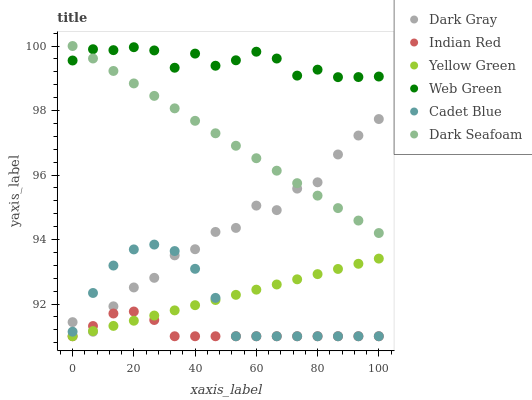Does Indian Red have the minimum area under the curve?
Answer yes or no. Yes. Does Web Green have the maximum area under the curve?
Answer yes or no. Yes. Does Yellow Green have the minimum area under the curve?
Answer yes or no. No. Does Yellow Green have the maximum area under the curve?
Answer yes or no. No. Is Yellow Green the smoothest?
Answer yes or no. Yes. Is Dark Gray the roughest?
Answer yes or no. Yes. Is Web Green the smoothest?
Answer yes or no. No. Is Web Green the roughest?
Answer yes or no. No. Does Cadet Blue have the lowest value?
Answer yes or no. Yes. Does Web Green have the lowest value?
Answer yes or no. No. Does Dark Seafoam have the highest value?
Answer yes or no. Yes. Does Yellow Green have the highest value?
Answer yes or no. No. Is Yellow Green less than Web Green?
Answer yes or no. Yes. Is Web Green greater than Indian Red?
Answer yes or no. Yes. Does Dark Gray intersect Indian Red?
Answer yes or no. Yes. Is Dark Gray less than Indian Red?
Answer yes or no. No. Is Dark Gray greater than Indian Red?
Answer yes or no. No. Does Yellow Green intersect Web Green?
Answer yes or no. No. 